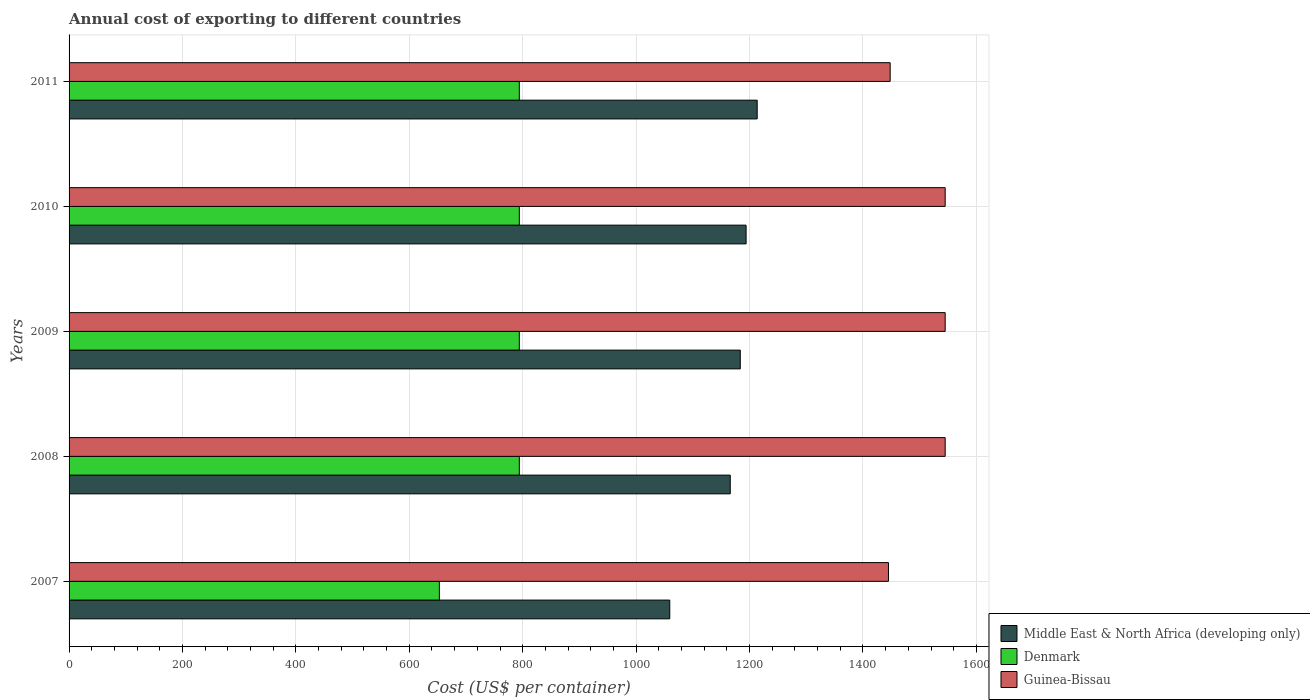How many bars are there on the 2nd tick from the top?
Provide a succinct answer. 3. How many bars are there on the 2nd tick from the bottom?
Your answer should be compact. 3. What is the label of the 4th group of bars from the top?
Make the answer very short. 2008. In how many cases, is the number of bars for a given year not equal to the number of legend labels?
Offer a very short reply. 0. What is the total annual cost of exporting in Guinea-Bissau in 2010?
Keep it short and to the point. 1545. Across all years, what is the maximum total annual cost of exporting in Guinea-Bissau?
Make the answer very short. 1545. Across all years, what is the minimum total annual cost of exporting in Guinea-Bissau?
Your response must be concise. 1445. In which year was the total annual cost of exporting in Denmark maximum?
Offer a terse response. 2008. What is the total total annual cost of exporting in Middle East & North Africa (developing only) in the graph?
Keep it short and to the point. 5816.42. What is the difference between the total annual cost of exporting in Guinea-Bissau in 2007 and that in 2010?
Offer a terse response. -100. What is the difference between the total annual cost of exporting in Denmark in 2010 and the total annual cost of exporting in Middle East & North Africa (developing only) in 2008?
Offer a terse response. -372. What is the average total annual cost of exporting in Guinea-Bissau per year?
Your answer should be very brief. 1505.6. In the year 2009, what is the difference between the total annual cost of exporting in Middle East & North Africa (developing only) and total annual cost of exporting in Denmark?
Your answer should be very brief. 389.67. In how many years, is the total annual cost of exporting in Denmark greater than 600 US$?
Keep it short and to the point. 5. What is the difference between the highest and the second highest total annual cost of exporting in Guinea-Bissau?
Offer a terse response. 0. What is the difference between the highest and the lowest total annual cost of exporting in Guinea-Bissau?
Provide a succinct answer. 100. In how many years, is the total annual cost of exporting in Guinea-Bissau greater than the average total annual cost of exporting in Guinea-Bissau taken over all years?
Offer a very short reply. 3. Is the sum of the total annual cost of exporting in Guinea-Bissau in 2008 and 2010 greater than the maximum total annual cost of exporting in Middle East & North Africa (developing only) across all years?
Provide a short and direct response. Yes. What does the 3rd bar from the bottom in 2008 represents?
Keep it short and to the point. Guinea-Bissau. How many bars are there?
Provide a short and direct response. 15. Are all the bars in the graph horizontal?
Keep it short and to the point. Yes. How many years are there in the graph?
Your answer should be compact. 5. Does the graph contain grids?
Provide a short and direct response. Yes. Where does the legend appear in the graph?
Your answer should be compact. Bottom right. How many legend labels are there?
Offer a terse response. 3. What is the title of the graph?
Ensure brevity in your answer.  Annual cost of exporting to different countries. What is the label or title of the X-axis?
Your answer should be very brief. Cost (US$ per container). What is the Cost (US$ per container) of Middle East & North Africa (developing only) in 2007?
Provide a short and direct response. 1059.33. What is the Cost (US$ per container) of Denmark in 2007?
Make the answer very short. 653. What is the Cost (US$ per container) of Guinea-Bissau in 2007?
Offer a terse response. 1445. What is the Cost (US$ per container) in Middle East & North Africa (developing only) in 2008?
Keep it short and to the point. 1166. What is the Cost (US$ per container) of Denmark in 2008?
Your answer should be very brief. 794. What is the Cost (US$ per container) in Guinea-Bissau in 2008?
Provide a short and direct response. 1545. What is the Cost (US$ per container) of Middle East & North Africa (developing only) in 2009?
Provide a succinct answer. 1183.67. What is the Cost (US$ per container) in Denmark in 2009?
Give a very brief answer. 794. What is the Cost (US$ per container) of Guinea-Bissau in 2009?
Offer a very short reply. 1545. What is the Cost (US$ per container) of Middle East & North Africa (developing only) in 2010?
Ensure brevity in your answer.  1193.92. What is the Cost (US$ per container) in Denmark in 2010?
Make the answer very short. 794. What is the Cost (US$ per container) of Guinea-Bissau in 2010?
Your answer should be compact. 1545. What is the Cost (US$ per container) in Middle East & North Africa (developing only) in 2011?
Your response must be concise. 1213.5. What is the Cost (US$ per container) of Denmark in 2011?
Make the answer very short. 794. What is the Cost (US$ per container) in Guinea-Bissau in 2011?
Make the answer very short. 1448. Across all years, what is the maximum Cost (US$ per container) of Middle East & North Africa (developing only)?
Give a very brief answer. 1213.5. Across all years, what is the maximum Cost (US$ per container) in Denmark?
Provide a short and direct response. 794. Across all years, what is the maximum Cost (US$ per container) in Guinea-Bissau?
Provide a succinct answer. 1545. Across all years, what is the minimum Cost (US$ per container) in Middle East & North Africa (developing only)?
Make the answer very short. 1059.33. Across all years, what is the minimum Cost (US$ per container) in Denmark?
Your response must be concise. 653. Across all years, what is the minimum Cost (US$ per container) in Guinea-Bissau?
Your answer should be very brief. 1445. What is the total Cost (US$ per container) of Middle East & North Africa (developing only) in the graph?
Keep it short and to the point. 5816.42. What is the total Cost (US$ per container) of Denmark in the graph?
Make the answer very short. 3829. What is the total Cost (US$ per container) of Guinea-Bissau in the graph?
Provide a succinct answer. 7528. What is the difference between the Cost (US$ per container) in Middle East & North Africa (developing only) in 2007 and that in 2008?
Your answer should be compact. -106.67. What is the difference between the Cost (US$ per container) in Denmark in 2007 and that in 2008?
Your answer should be very brief. -141. What is the difference between the Cost (US$ per container) of Guinea-Bissau in 2007 and that in 2008?
Offer a very short reply. -100. What is the difference between the Cost (US$ per container) of Middle East & North Africa (developing only) in 2007 and that in 2009?
Your answer should be compact. -124.33. What is the difference between the Cost (US$ per container) in Denmark in 2007 and that in 2009?
Provide a short and direct response. -141. What is the difference between the Cost (US$ per container) in Guinea-Bissau in 2007 and that in 2009?
Provide a short and direct response. -100. What is the difference between the Cost (US$ per container) of Middle East & North Africa (developing only) in 2007 and that in 2010?
Provide a succinct answer. -134.58. What is the difference between the Cost (US$ per container) in Denmark in 2007 and that in 2010?
Offer a very short reply. -141. What is the difference between the Cost (US$ per container) of Guinea-Bissau in 2007 and that in 2010?
Your response must be concise. -100. What is the difference between the Cost (US$ per container) in Middle East & North Africa (developing only) in 2007 and that in 2011?
Provide a succinct answer. -154.17. What is the difference between the Cost (US$ per container) of Denmark in 2007 and that in 2011?
Ensure brevity in your answer.  -141. What is the difference between the Cost (US$ per container) of Middle East & North Africa (developing only) in 2008 and that in 2009?
Your answer should be compact. -17.67. What is the difference between the Cost (US$ per container) of Middle East & North Africa (developing only) in 2008 and that in 2010?
Give a very brief answer. -27.92. What is the difference between the Cost (US$ per container) in Middle East & North Africa (developing only) in 2008 and that in 2011?
Your answer should be very brief. -47.5. What is the difference between the Cost (US$ per container) of Guinea-Bissau in 2008 and that in 2011?
Ensure brevity in your answer.  97. What is the difference between the Cost (US$ per container) of Middle East & North Africa (developing only) in 2009 and that in 2010?
Ensure brevity in your answer.  -10.25. What is the difference between the Cost (US$ per container) in Guinea-Bissau in 2009 and that in 2010?
Offer a terse response. 0. What is the difference between the Cost (US$ per container) in Middle East & North Africa (developing only) in 2009 and that in 2011?
Make the answer very short. -29.83. What is the difference between the Cost (US$ per container) of Denmark in 2009 and that in 2011?
Provide a succinct answer. 0. What is the difference between the Cost (US$ per container) of Guinea-Bissau in 2009 and that in 2011?
Offer a terse response. 97. What is the difference between the Cost (US$ per container) of Middle East & North Africa (developing only) in 2010 and that in 2011?
Make the answer very short. -19.58. What is the difference between the Cost (US$ per container) in Guinea-Bissau in 2010 and that in 2011?
Offer a terse response. 97. What is the difference between the Cost (US$ per container) in Middle East & North Africa (developing only) in 2007 and the Cost (US$ per container) in Denmark in 2008?
Give a very brief answer. 265.33. What is the difference between the Cost (US$ per container) of Middle East & North Africa (developing only) in 2007 and the Cost (US$ per container) of Guinea-Bissau in 2008?
Ensure brevity in your answer.  -485.67. What is the difference between the Cost (US$ per container) of Denmark in 2007 and the Cost (US$ per container) of Guinea-Bissau in 2008?
Offer a very short reply. -892. What is the difference between the Cost (US$ per container) in Middle East & North Africa (developing only) in 2007 and the Cost (US$ per container) in Denmark in 2009?
Make the answer very short. 265.33. What is the difference between the Cost (US$ per container) in Middle East & North Africa (developing only) in 2007 and the Cost (US$ per container) in Guinea-Bissau in 2009?
Provide a succinct answer. -485.67. What is the difference between the Cost (US$ per container) in Denmark in 2007 and the Cost (US$ per container) in Guinea-Bissau in 2009?
Your answer should be very brief. -892. What is the difference between the Cost (US$ per container) in Middle East & North Africa (developing only) in 2007 and the Cost (US$ per container) in Denmark in 2010?
Offer a terse response. 265.33. What is the difference between the Cost (US$ per container) of Middle East & North Africa (developing only) in 2007 and the Cost (US$ per container) of Guinea-Bissau in 2010?
Provide a succinct answer. -485.67. What is the difference between the Cost (US$ per container) of Denmark in 2007 and the Cost (US$ per container) of Guinea-Bissau in 2010?
Give a very brief answer. -892. What is the difference between the Cost (US$ per container) of Middle East & North Africa (developing only) in 2007 and the Cost (US$ per container) of Denmark in 2011?
Provide a succinct answer. 265.33. What is the difference between the Cost (US$ per container) of Middle East & North Africa (developing only) in 2007 and the Cost (US$ per container) of Guinea-Bissau in 2011?
Ensure brevity in your answer.  -388.67. What is the difference between the Cost (US$ per container) of Denmark in 2007 and the Cost (US$ per container) of Guinea-Bissau in 2011?
Your response must be concise. -795. What is the difference between the Cost (US$ per container) of Middle East & North Africa (developing only) in 2008 and the Cost (US$ per container) of Denmark in 2009?
Your response must be concise. 372. What is the difference between the Cost (US$ per container) of Middle East & North Africa (developing only) in 2008 and the Cost (US$ per container) of Guinea-Bissau in 2009?
Keep it short and to the point. -379. What is the difference between the Cost (US$ per container) of Denmark in 2008 and the Cost (US$ per container) of Guinea-Bissau in 2009?
Give a very brief answer. -751. What is the difference between the Cost (US$ per container) of Middle East & North Africa (developing only) in 2008 and the Cost (US$ per container) of Denmark in 2010?
Offer a very short reply. 372. What is the difference between the Cost (US$ per container) in Middle East & North Africa (developing only) in 2008 and the Cost (US$ per container) in Guinea-Bissau in 2010?
Ensure brevity in your answer.  -379. What is the difference between the Cost (US$ per container) in Denmark in 2008 and the Cost (US$ per container) in Guinea-Bissau in 2010?
Provide a succinct answer. -751. What is the difference between the Cost (US$ per container) of Middle East & North Africa (developing only) in 2008 and the Cost (US$ per container) of Denmark in 2011?
Make the answer very short. 372. What is the difference between the Cost (US$ per container) in Middle East & North Africa (developing only) in 2008 and the Cost (US$ per container) in Guinea-Bissau in 2011?
Ensure brevity in your answer.  -282. What is the difference between the Cost (US$ per container) in Denmark in 2008 and the Cost (US$ per container) in Guinea-Bissau in 2011?
Provide a succinct answer. -654. What is the difference between the Cost (US$ per container) in Middle East & North Africa (developing only) in 2009 and the Cost (US$ per container) in Denmark in 2010?
Provide a short and direct response. 389.67. What is the difference between the Cost (US$ per container) of Middle East & North Africa (developing only) in 2009 and the Cost (US$ per container) of Guinea-Bissau in 2010?
Provide a succinct answer. -361.33. What is the difference between the Cost (US$ per container) in Denmark in 2009 and the Cost (US$ per container) in Guinea-Bissau in 2010?
Your response must be concise. -751. What is the difference between the Cost (US$ per container) of Middle East & North Africa (developing only) in 2009 and the Cost (US$ per container) of Denmark in 2011?
Your response must be concise. 389.67. What is the difference between the Cost (US$ per container) in Middle East & North Africa (developing only) in 2009 and the Cost (US$ per container) in Guinea-Bissau in 2011?
Keep it short and to the point. -264.33. What is the difference between the Cost (US$ per container) in Denmark in 2009 and the Cost (US$ per container) in Guinea-Bissau in 2011?
Make the answer very short. -654. What is the difference between the Cost (US$ per container) in Middle East & North Africa (developing only) in 2010 and the Cost (US$ per container) in Denmark in 2011?
Make the answer very short. 399.92. What is the difference between the Cost (US$ per container) in Middle East & North Africa (developing only) in 2010 and the Cost (US$ per container) in Guinea-Bissau in 2011?
Your answer should be compact. -254.08. What is the difference between the Cost (US$ per container) of Denmark in 2010 and the Cost (US$ per container) of Guinea-Bissau in 2011?
Your answer should be very brief. -654. What is the average Cost (US$ per container) of Middle East & North Africa (developing only) per year?
Your response must be concise. 1163.28. What is the average Cost (US$ per container) in Denmark per year?
Keep it short and to the point. 765.8. What is the average Cost (US$ per container) of Guinea-Bissau per year?
Ensure brevity in your answer.  1505.6. In the year 2007, what is the difference between the Cost (US$ per container) of Middle East & North Africa (developing only) and Cost (US$ per container) of Denmark?
Provide a succinct answer. 406.33. In the year 2007, what is the difference between the Cost (US$ per container) of Middle East & North Africa (developing only) and Cost (US$ per container) of Guinea-Bissau?
Offer a very short reply. -385.67. In the year 2007, what is the difference between the Cost (US$ per container) in Denmark and Cost (US$ per container) in Guinea-Bissau?
Give a very brief answer. -792. In the year 2008, what is the difference between the Cost (US$ per container) in Middle East & North Africa (developing only) and Cost (US$ per container) in Denmark?
Ensure brevity in your answer.  372. In the year 2008, what is the difference between the Cost (US$ per container) of Middle East & North Africa (developing only) and Cost (US$ per container) of Guinea-Bissau?
Give a very brief answer. -379. In the year 2008, what is the difference between the Cost (US$ per container) of Denmark and Cost (US$ per container) of Guinea-Bissau?
Offer a very short reply. -751. In the year 2009, what is the difference between the Cost (US$ per container) of Middle East & North Africa (developing only) and Cost (US$ per container) of Denmark?
Your response must be concise. 389.67. In the year 2009, what is the difference between the Cost (US$ per container) in Middle East & North Africa (developing only) and Cost (US$ per container) in Guinea-Bissau?
Your answer should be very brief. -361.33. In the year 2009, what is the difference between the Cost (US$ per container) of Denmark and Cost (US$ per container) of Guinea-Bissau?
Offer a very short reply. -751. In the year 2010, what is the difference between the Cost (US$ per container) of Middle East & North Africa (developing only) and Cost (US$ per container) of Denmark?
Provide a succinct answer. 399.92. In the year 2010, what is the difference between the Cost (US$ per container) in Middle East & North Africa (developing only) and Cost (US$ per container) in Guinea-Bissau?
Your answer should be compact. -351.08. In the year 2010, what is the difference between the Cost (US$ per container) of Denmark and Cost (US$ per container) of Guinea-Bissau?
Your response must be concise. -751. In the year 2011, what is the difference between the Cost (US$ per container) in Middle East & North Africa (developing only) and Cost (US$ per container) in Denmark?
Your answer should be compact. 419.5. In the year 2011, what is the difference between the Cost (US$ per container) of Middle East & North Africa (developing only) and Cost (US$ per container) of Guinea-Bissau?
Your response must be concise. -234.5. In the year 2011, what is the difference between the Cost (US$ per container) in Denmark and Cost (US$ per container) in Guinea-Bissau?
Your answer should be very brief. -654. What is the ratio of the Cost (US$ per container) in Middle East & North Africa (developing only) in 2007 to that in 2008?
Ensure brevity in your answer.  0.91. What is the ratio of the Cost (US$ per container) of Denmark in 2007 to that in 2008?
Provide a short and direct response. 0.82. What is the ratio of the Cost (US$ per container) in Guinea-Bissau in 2007 to that in 2008?
Provide a succinct answer. 0.94. What is the ratio of the Cost (US$ per container) of Middle East & North Africa (developing only) in 2007 to that in 2009?
Make the answer very short. 0.9. What is the ratio of the Cost (US$ per container) in Denmark in 2007 to that in 2009?
Ensure brevity in your answer.  0.82. What is the ratio of the Cost (US$ per container) in Guinea-Bissau in 2007 to that in 2009?
Your response must be concise. 0.94. What is the ratio of the Cost (US$ per container) in Middle East & North Africa (developing only) in 2007 to that in 2010?
Your response must be concise. 0.89. What is the ratio of the Cost (US$ per container) in Denmark in 2007 to that in 2010?
Offer a very short reply. 0.82. What is the ratio of the Cost (US$ per container) of Guinea-Bissau in 2007 to that in 2010?
Your response must be concise. 0.94. What is the ratio of the Cost (US$ per container) in Middle East & North Africa (developing only) in 2007 to that in 2011?
Your response must be concise. 0.87. What is the ratio of the Cost (US$ per container) of Denmark in 2007 to that in 2011?
Your answer should be compact. 0.82. What is the ratio of the Cost (US$ per container) of Guinea-Bissau in 2007 to that in 2011?
Give a very brief answer. 1. What is the ratio of the Cost (US$ per container) in Middle East & North Africa (developing only) in 2008 to that in 2009?
Offer a very short reply. 0.99. What is the ratio of the Cost (US$ per container) of Guinea-Bissau in 2008 to that in 2009?
Offer a very short reply. 1. What is the ratio of the Cost (US$ per container) in Middle East & North Africa (developing only) in 2008 to that in 2010?
Your answer should be very brief. 0.98. What is the ratio of the Cost (US$ per container) in Denmark in 2008 to that in 2010?
Keep it short and to the point. 1. What is the ratio of the Cost (US$ per container) of Middle East & North Africa (developing only) in 2008 to that in 2011?
Your answer should be compact. 0.96. What is the ratio of the Cost (US$ per container) in Denmark in 2008 to that in 2011?
Ensure brevity in your answer.  1. What is the ratio of the Cost (US$ per container) in Guinea-Bissau in 2008 to that in 2011?
Offer a terse response. 1.07. What is the ratio of the Cost (US$ per container) in Guinea-Bissau in 2009 to that in 2010?
Your answer should be compact. 1. What is the ratio of the Cost (US$ per container) of Middle East & North Africa (developing only) in 2009 to that in 2011?
Ensure brevity in your answer.  0.98. What is the ratio of the Cost (US$ per container) of Denmark in 2009 to that in 2011?
Provide a short and direct response. 1. What is the ratio of the Cost (US$ per container) in Guinea-Bissau in 2009 to that in 2011?
Keep it short and to the point. 1.07. What is the ratio of the Cost (US$ per container) in Middle East & North Africa (developing only) in 2010 to that in 2011?
Provide a short and direct response. 0.98. What is the ratio of the Cost (US$ per container) in Guinea-Bissau in 2010 to that in 2011?
Ensure brevity in your answer.  1.07. What is the difference between the highest and the second highest Cost (US$ per container) in Middle East & North Africa (developing only)?
Your answer should be compact. 19.58. What is the difference between the highest and the second highest Cost (US$ per container) of Guinea-Bissau?
Give a very brief answer. 0. What is the difference between the highest and the lowest Cost (US$ per container) of Middle East & North Africa (developing only)?
Your answer should be compact. 154.17. What is the difference between the highest and the lowest Cost (US$ per container) of Denmark?
Provide a succinct answer. 141. What is the difference between the highest and the lowest Cost (US$ per container) of Guinea-Bissau?
Your response must be concise. 100. 